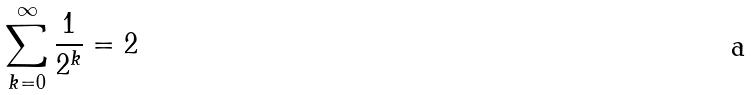<formula> <loc_0><loc_0><loc_500><loc_500>\sum _ { k = 0 } ^ { \infty } \frac { 1 } { 2 ^ { k } } = 2</formula> 